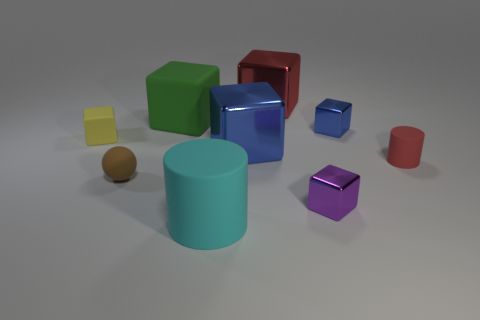Subtract all yellow blocks. How many blocks are left? 5 Subtract all small yellow rubber blocks. How many blocks are left? 5 Subtract all yellow blocks. Subtract all blue cylinders. How many blocks are left? 5 Add 1 big metallic cylinders. How many objects exist? 10 Subtract all blocks. How many objects are left? 3 Add 9 big brown spheres. How many big brown spheres exist? 9 Subtract 1 red cylinders. How many objects are left? 8 Subtract all small metallic objects. Subtract all tiny purple things. How many objects are left? 6 Add 9 large blue things. How many large blue things are left? 10 